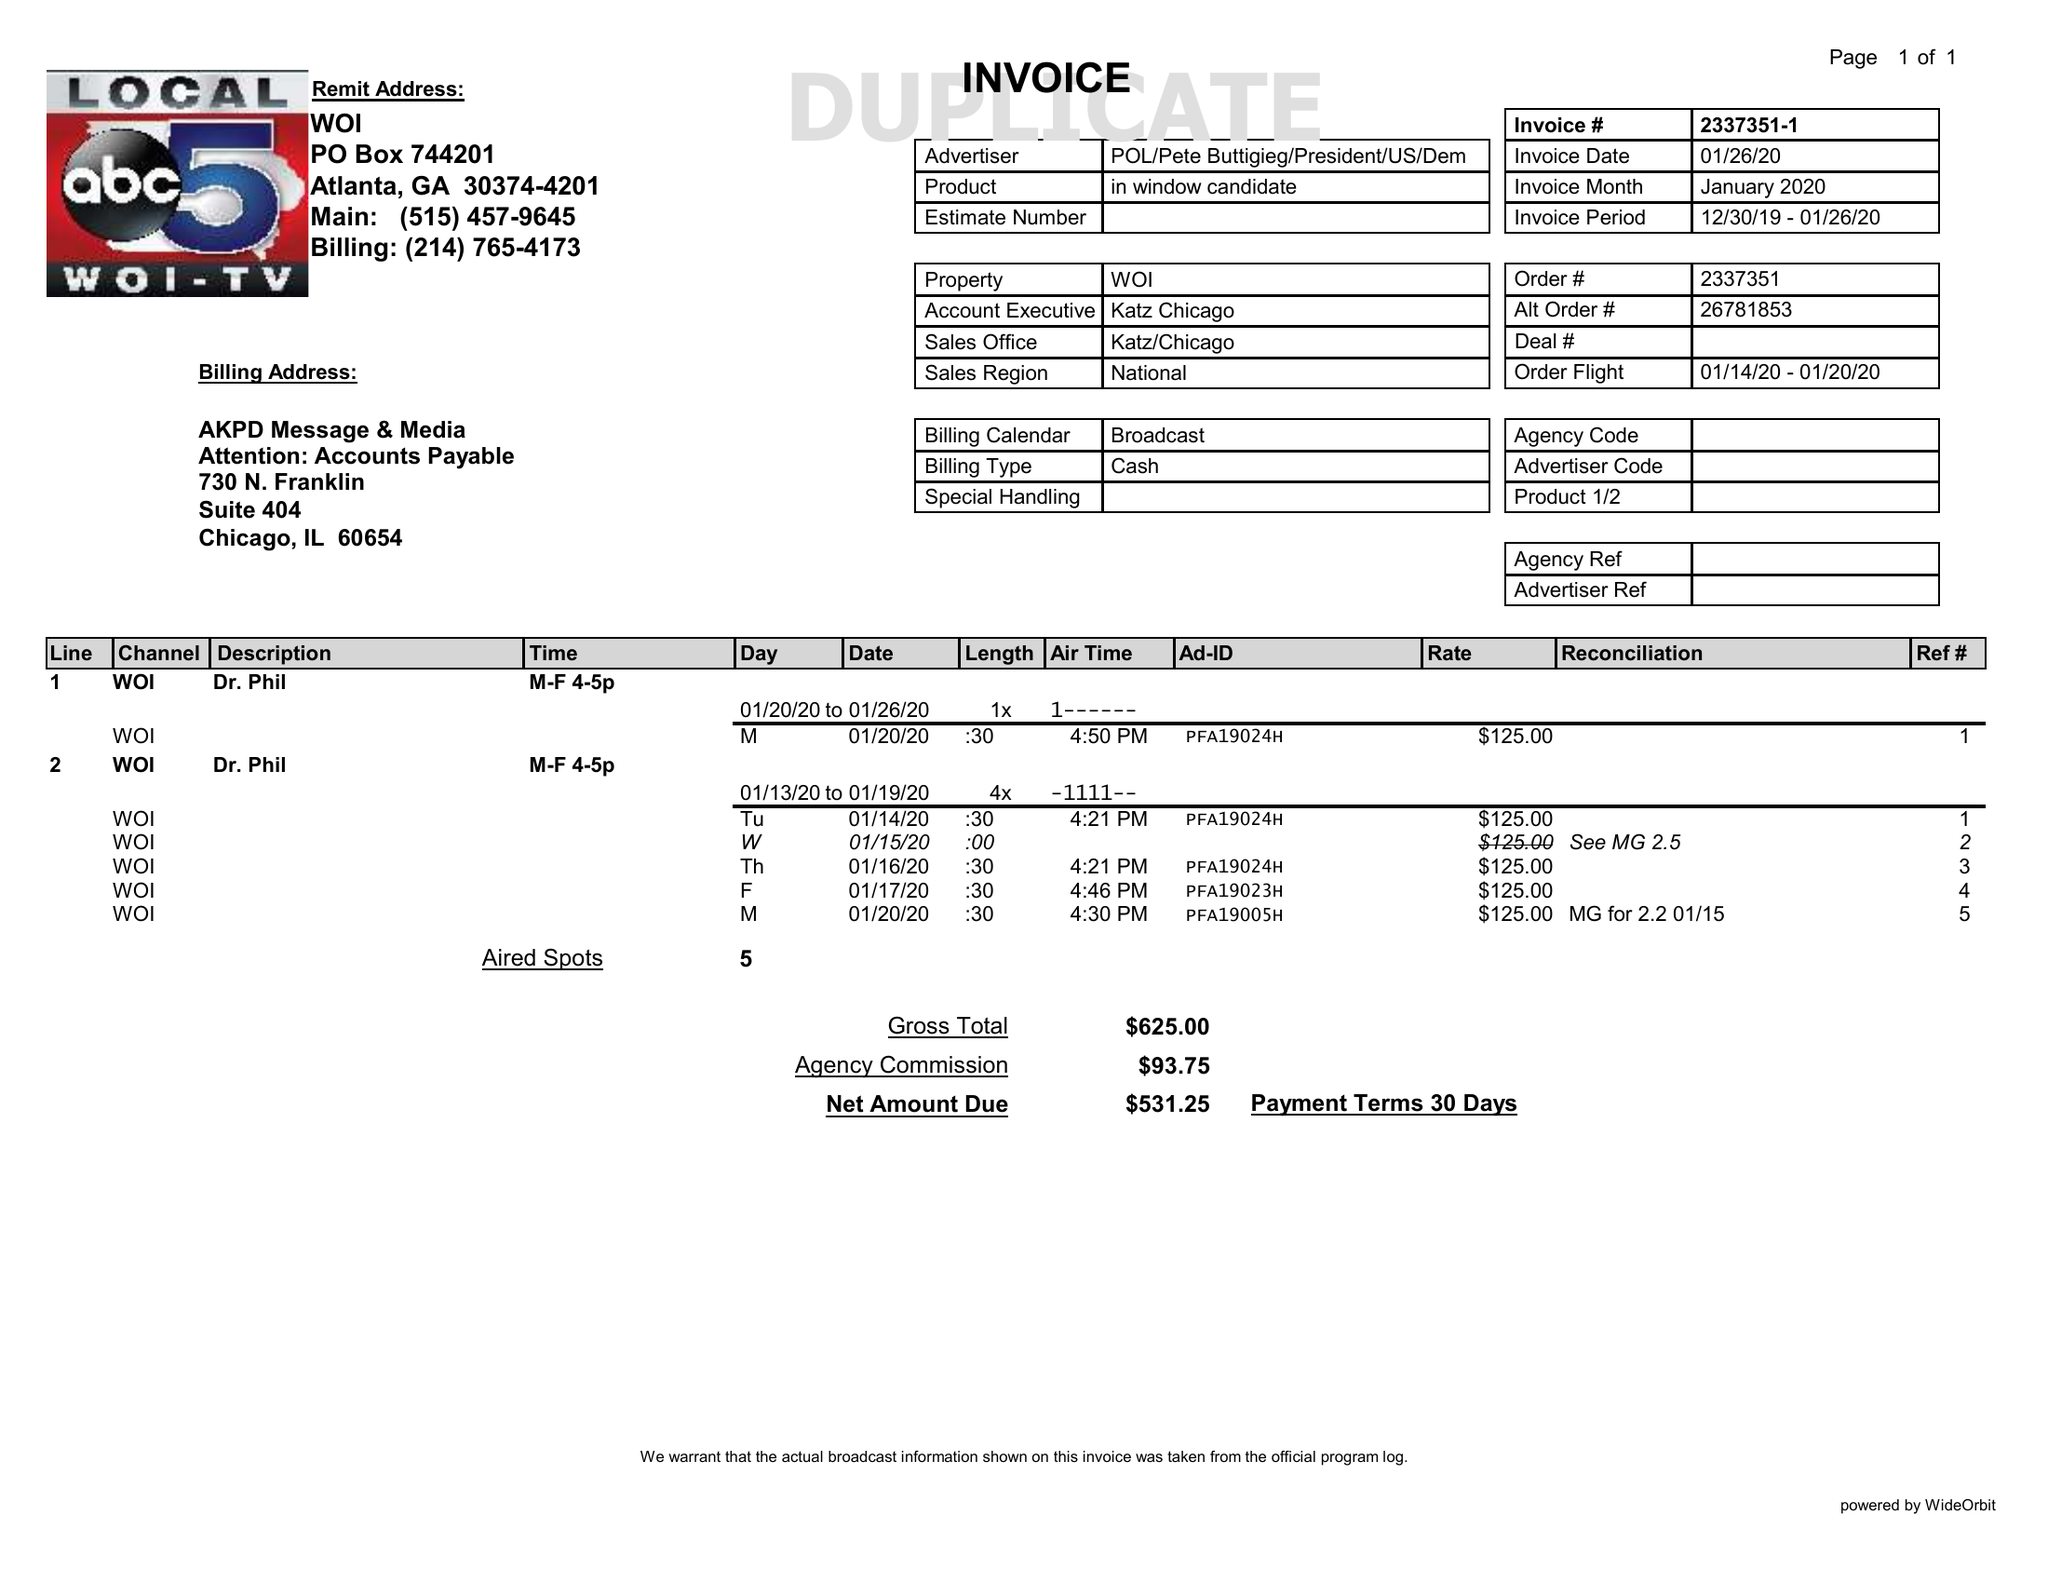What is the value for the contract_num?
Answer the question using a single word or phrase. 2337351 